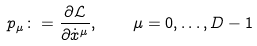Convert formula to latex. <formula><loc_0><loc_0><loc_500><loc_500>p _ { \mu } \colon = \frac { \partial \mathcal { L } } { \partial \dot { x } ^ { \mu } } , \quad \mu = 0 , \dots , D - 1</formula> 